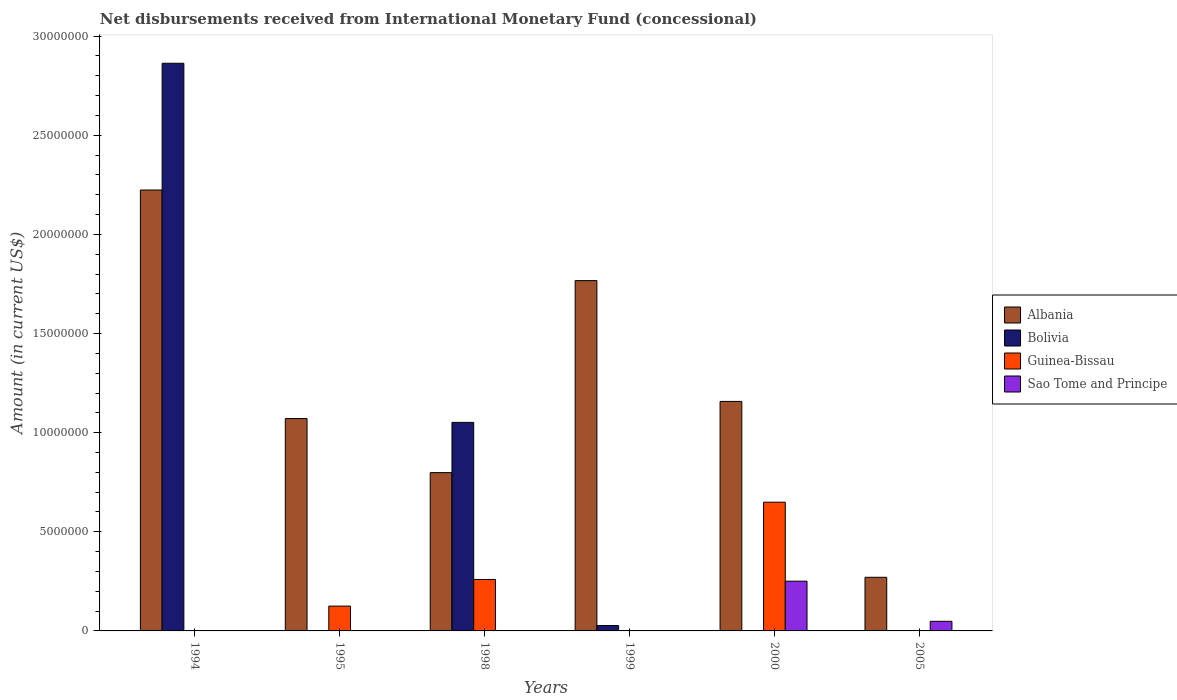How many different coloured bars are there?
Provide a short and direct response. 4. How many groups of bars are there?
Your answer should be compact. 6. Are the number of bars on each tick of the X-axis equal?
Keep it short and to the point. No. In how many cases, is the number of bars for a given year not equal to the number of legend labels?
Make the answer very short. 6. What is the amount of disbursements received from International Monetary Fund in Albania in 2005?
Provide a short and direct response. 2.70e+06. Across all years, what is the maximum amount of disbursements received from International Monetary Fund in Sao Tome and Principe?
Provide a succinct answer. 2.51e+06. Across all years, what is the minimum amount of disbursements received from International Monetary Fund in Albania?
Give a very brief answer. 2.70e+06. What is the total amount of disbursements received from International Monetary Fund in Guinea-Bissau in the graph?
Your answer should be compact. 1.03e+07. What is the difference between the amount of disbursements received from International Monetary Fund in Albania in 1995 and that in 1998?
Give a very brief answer. 2.73e+06. What is the difference between the amount of disbursements received from International Monetary Fund in Albania in 2000 and the amount of disbursements received from International Monetary Fund in Bolivia in 1995?
Keep it short and to the point. 1.16e+07. What is the average amount of disbursements received from International Monetary Fund in Albania per year?
Offer a very short reply. 1.21e+07. In the year 1994, what is the difference between the amount of disbursements received from International Monetary Fund in Albania and amount of disbursements received from International Monetary Fund in Bolivia?
Your response must be concise. -6.39e+06. In how many years, is the amount of disbursements received from International Monetary Fund in Guinea-Bissau greater than 6000000 US$?
Your response must be concise. 1. What is the difference between the highest and the second highest amount of disbursements received from International Monetary Fund in Albania?
Provide a succinct answer. 4.57e+06. What is the difference between the highest and the lowest amount of disbursements received from International Monetary Fund in Albania?
Offer a terse response. 1.95e+07. Is the sum of the amount of disbursements received from International Monetary Fund in Albania in 1994 and 1998 greater than the maximum amount of disbursements received from International Monetary Fund in Guinea-Bissau across all years?
Your answer should be compact. Yes. Is it the case that in every year, the sum of the amount of disbursements received from International Monetary Fund in Albania and amount of disbursements received from International Monetary Fund in Sao Tome and Principe is greater than the sum of amount of disbursements received from International Monetary Fund in Bolivia and amount of disbursements received from International Monetary Fund in Guinea-Bissau?
Ensure brevity in your answer.  Yes. Is it the case that in every year, the sum of the amount of disbursements received from International Monetary Fund in Albania and amount of disbursements received from International Monetary Fund in Guinea-Bissau is greater than the amount of disbursements received from International Monetary Fund in Sao Tome and Principe?
Provide a succinct answer. Yes. How many bars are there?
Provide a succinct answer. 14. What is the difference between two consecutive major ticks on the Y-axis?
Provide a succinct answer. 5.00e+06. How many legend labels are there?
Provide a short and direct response. 4. How are the legend labels stacked?
Provide a short and direct response. Vertical. What is the title of the graph?
Your answer should be compact. Net disbursements received from International Monetary Fund (concessional). Does "United Kingdom" appear as one of the legend labels in the graph?
Give a very brief answer. No. What is the Amount (in current US$) in Albania in 1994?
Give a very brief answer. 2.22e+07. What is the Amount (in current US$) of Bolivia in 1994?
Ensure brevity in your answer.  2.86e+07. What is the Amount (in current US$) of Guinea-Bissau in 1994?
Ensure brevity in your answer.  0. What is the Amount (in current US$) of Sao Tome and Principe in 1994?
Your answer should be compact. 0. What is the Amount (in current US$) of Albania in 1995?
Your answer should be very brief. 1.07e+07. What is the Amount (in current US$) of Guinea-Bissau in 1995?
Your answer should be very brief. 1.25e+06. What is the Amount (in current US$) of Sao Tome and Principe in 1995?
Keep it short and to the point. 0. What is the Amount (in current US$) in Albania in 1998?
Your response must be concise. 7.98e+06. What is the Amount (in current US$) of Bolivia in 1998?
Give a very brief answer. 1.05e+07. What is the Amount (in current US$) in Guinea-Bissau in 1998?
Keep it short and to the point. 2.60e+06. What is the Amount (in current US$) of Sao Tome and Principe in 1998?
Provide a short and direct response. 0. What is the Amount (in current US$) in Albania in 1999?
Provide a short and direct response. 1.77e+07. What is the Amount (in current US$) in Bolivia in 1999?
Make the answer very short. 2.72e+05. What is the Amount (in current US$) in Sao Tome and Principe in 1999?
Ensure brevity in your answer.  0. What is the Amount (in current US$) of Albania in 2000?
Ensure brevity in your answer.  1.16e+07. What is the Amount (in current US$) of Bolivia in 2000?
Provide a succinct answer. 0. What is the Amount (in current US$) of Guinea-Bissau in 2000?
Offer a terse response. 6.49e+06. What is the Amount (in current US$) of Sao Tome and Principe in 2000?
Give a very brief answer. 2.51e+06. What is the Amount (in current US$) of Albania in 2005?
Make the answer very short. 2.70e+06. What is the Amount (in current US$) in Bolivia in 2005?
Offer a very short reply. 0. What is the Amount (in current US$) in Sao Tome and Principe in 2005?
Make the answer very short. 4.85e+05. Across all years, what is the maximum Amount (in current US$) in Albania?
Your response must be concise. 2.22e+07. Across all years, what is the maximum Amount (in current US$) in Bolivia?
Your response must be concise. 2.86e+07. Across all years, what is the maximum Amount (in current US$) of Guinea-Bissau?
Offer a terse response. 6.49e+06. Across all years, what is the maximum Amount (in current US$) in Sao Tome and Principe?
Keep it short and to the point. 2.51e+06. Across all years, what is the minimum Amount (in current US$) of Albania?
Give a very brief answer. 2.70e+06. Across all years, what is the minimum Amount (in current US$) of Bolivia?
Offer a terse response. 0. Across all years, what is the minimum Amount (in current US$) of Sao Tome and Principe?
Offer a terse response. 0. What is the total Amount (in current US$) in Albania in the graph?
Give a very brief answer. 7.29e+07. What is the total Amount (in current US$) of Bolivia in the graph?
Make the answer very short. 3.94e+07. What is the total Amount (in current US$) of Guinea-Bissau in the graph?
Give a very brief answer. 1.03e+07. What is the total Amount (in current US$) of Sao Tome and Principe in the graph?
Keep it short and to the point. 2.99e+06. What is the difference between the Amount (in current US$) of Albania in 1994 and that in 1995?
Offer a terse response. 1.15e+07. What is the difference between the Amount (in current US$) in Albania in 1994 and that in 1998?
Provide a succinct answer. 1.43e+07. What is the difference between the Amount (in current US$) in Bolivia in 1994 and that in 1998?
Your answer should be compact. 1.81e+07. What is the difference between the Amount (in current US$) of Albania in 1994 and that in 1999?
Offer a terse response. 4.57e+06. What is the difference between the Amount (in current US$) in Bolivia in 1994 and that in 1999?
Give a very brief answer. 2.84e+07. What is the difference between the Amount (in current US$) of Albania in 1994 and that in 2000?
Ensure brevity in your answer.  1.07e+07. What is the difference between the Amount (in current US$) of Albania in 1994 and that in 2005?
Give a very brief answer. 1.95e+07. What is the difference between the Amount (in current US$) in Albania in 1995 and that in 1998?
Keep it short and to the point. 2.73e+06. What is the difference between the Amount (in current US$) in Guinea-Bissau in 1995 and that in 1998?
Provide a short and direct response. -1.34e+06. What is the difference between the Amount (in current US$) of Albania in 1995 and that in 1999?
Offer a very short reply. -6.96e+06. What is the difference between the Amount (in current US$) of Albania in 1995 and that in 2000?
Make the answer very short. -8.64e+05. What is the difference between the Amount (in current US$) of Guinea-Bissau in 1995 and that in 2000?
Keep it short and to the point. -5.24e+06. What is the difference between the Amount (in current US$) in Albania in 1995 and that in 2005?
Your answer should be very brief. 8.01e+06. What is the difference between the Amount (in current US$) in Albania in 1998 and that in 1999?
Your response must be concise. -9.68e+06. What is the difference between the Amount (in current US$) in Bolivia in 1998 and that in 1999?
Ensure brevity in your answer.  1.02e+07. What is the difference between the Amount (in current US$) in Albania in 1998 and that in 2000?
Your answer should be compact. -3.59e+06. What is the difference between the Amount (in current US$) in Guinea-Bissau in 1998 and that in 2000?
Make the answer very short. -3.90e+06. What is the difference between the Amount (in current US$) in Albania in 1998 and that in 2005?
Keep it short and to the point. 5.28e+06. What is the difference between the Amount (in current US$) in Albania in 1999 and that in 2000?
Your answer should be compact. 6.09e+06. What is the difference between the Amount (in current US$) of Albania in 1999 and that in 2005?
Your answer should be compact. 1.50e+07. What is the difference between the Amount (in current US$) in Albania in 2000 and that in 2005?
Your response must be concise. 8.87e+06. What is the difference between the Amount (in current US$) of Sao Tome and Principe in 2000 and that in 2005?
Your answer should be compact. 2.02e+06. What is the difference between the Amount (in current US$) in Albania in 1994 and the Amount (in current US$) in Guinea-Bissau in 1995?
Your answer should be compact. 2.10e+07. What is the difference between the Amount (in current US$) of Bolivia in 1994 and the Amount (in current US$) of Guinea-Bissau in 1995?
Keep it short and to the point. 2.74e+07. What is the difference between the Amount (in current US$) in Albania in 1994 and the Amount (in current US$) in Bolivia in 1998?
Give a very brief answer. 1.17e+07. What is the difference between the Amount (in current US$) in Albania in 1994 and the Amount (in current US$) in Guinea-Bissau in 1998?
Make the answer very short. 1.96e+07. What is the difference between the Amount (in current US$) in Bolivia in 1994 and the Amount (in current US$) in Guinea-Bissau in 1998?
Provide a short and direct response. 2.60e+07. What is the difference between the Amount (in current US$) of Albania in 1994 and the Amount (in current US$) of Bolivia in 1999?
Offer a very short reply. 2.20e+07. What is the difference between the Amount (in current US$) in Albania in 1994 and the Amount (in current US$) in Guinea-Bissau in 2000?
Your answer should be very brief. 1.57e+07. What is the difference between the Amount (in current US$) of Albania in 1994 and the Amount (in current US$) of Sao Tome and Principe in 2000?
Provide a succinct answer. 1.97e+07. What is the difference between the Amount (in current US$) in Bolivia in 1994 and the Amount (in current US$) in Guinea-Bissau in 2000?
Give a very brief answer. 2.21e+07. What is the difference between the Amount (in current US$) of Bolivia in 1994 and the Amount (in current US$) of Sao Tome and Principe in 2000?
Make the answer very short. 2.61e+07. What is the difference between the Amount (in current US$) in Albania in 1994 and the Amount (in current US$) in Sao Tome and Principe in 2005?
Make the answer very short. 2.18e+07. What is the difference between the Amount (in current US$) of Bolivia in 1994 and the Amount (in current US$) of Sao Tome and Principe in 2005?
Give a very brief answer. 2.81e+07. What is the difference between the Amount (in current US$) in Albania in 1995 and the Amount (in current US$) in Bolivia in 1998?
Your response must be concise. 1.93e+05. What is the difference between the Amount (in current US$) in Albania in 1995 and the Amount (in current US$) in Guinea-Bissau in 1998?
Give a very brief answer. 8.12e+06. What is the difference between the Amount (in current US$) in Albania in 1995 and the Amount (in current US$) in Bolivia in 1999?
Offer a terse response. 1.04e+07. What is the difference between the Amount (in current US$) of Albania in 1995 and the Amount (in current US$) of Guinea-Bissau in 2000?
Provide a short and direct response. 4.22e+06. What is the difference between the Amount (in current US$) in Albania in 1995 and the Amount (in current US$) in Sao Tome and Principe in 2000?
Offer a very short reply. 8.20e+06. What is the difference between the Amount (in current US$) in Guinea-Bissau in 1995 and the Amount (in current US$) in Sao Tome and Principe in 2000?
Give a very brief answer. -1.26e+06. What is the difference between the Amount (in current US$) of Albania in 1995 and the Amount (in current US$) of Sao Tome and Principe in 2005?
Offer a very short reply. 1.02e+07. What is the difference between the Amount (in current US$) of Guinea-Bissau in 1995 and the Amount (in current US$) of Sao Tome and Principe in 2005?
Offer a very short reply. 7.67e+05. What is the difference between the Amount (in current US$) in Albania in 1998 and the Amount (in current US$) in Bolivia in 1999?
Offer a very short reply. 7.71e+06. What is the difference between the Amount (in current US$) in Albania in 1998 and the Amount (in current US$) in Guinea-Bissau in 2000?
Provide a succinct answer. 1.49e+06. What is the difference between the Amount (in current US$) in Albania in 1998 and the Amount (in current US$) in Sao Tome and Principe in 2000?
Provide a succinct answer. 5.48e+06. What is the difference between the Amount (in current US$) in Bolivia in 1998 and the Amount (in current US$) in Guinea-Bissau in 2000?
Give a very brief answer. 4.03e+06. What is the difference between the Amount (in current US$) in Bolivia in 1998 and the Amount (in current US$) in Sao Tome and Principe in 2000?
Provide a short and direct response. 8.01e+06. What is the difference between the Amount (in current US$) of Guinea-Bissau in 1998 and the Amount (in current US$) of Sao Tome and Principe in 2000?
Provide a short and direct response. 8.60e+04. What is the difference between the Amount (in current US$) of Albania in 1998 and the Amount (in current US$) of Sao Tome and Principe in 2005?
Give a very brief answer. 7.50e+06. What is the difference between the Amount (in current US$) in Bolivia in 1998 and the Amount (in current US$) in Sao Tome and Principe in 2005?
Ensure brevity in your answer.  1.00e+07. What is the difference between the Amount (in current US$) in Guinea-Bissau in 1998 and the Amount (in current US$) in Sao Tome and Principe in 2005?
Your response must be concise. 2.11e+06. What is the difference between the Amount (in current US$) in Albania in 1999 and the Amount (in current US$) in Guinea-Bissau in 2000?
Make the answer very short. 1.12e+07. What is the difference between the Amount (in current US$) in Albania in 1999 and the Amount (in current US$) in Sao Tome and Principe in 2000?
Give a very brief answer. 1.52e+07. What is the difference between the Amount (in current US$) in Bolivia in 1999 and the Amount (in current US$) in Guinea-Bissau in 2000?
Your answer should be very brief. -6.22e+06. What is the difference between the Amount (in current US$) of Bolivia in 1999 and the Amount (in current US$) of Sao Tome and Principe in 2000?
Your response must be concise. -2.24e+06. What is the difference between the Amount (in current US$) of Albania in 1999 and the Amount (in current US$) of Sao Tome and Principe in 2005?
Make the answer very short. 1.72e+07. What is the difference between the Amount (in current US$) of Bolivia in 1999 and the Amount (in current US$) of Sao Tome and Principe in 2005?
Ensure brevity in your answer.  -2.13e+05. What is the difference between the Amount (in current US$) of Albania in 2000 and the Amount (in current US$) of Sao Tome and Principe in 2005?
Ensure brevity in your answer.  1.11e+07. What is the difference between the Amount (in current US$) in Guinea-Bissau in 2000 and the Amount (in current US$) in Sao Tome and Principe in 2005?
Your answer should be very brief. 6.01e+06. What is the average Amount (in current US$) of Albania per year?
Make the answer very short. 1.21e+07. What is the average Amount (in current US$) in Bolivia per year?
Your answer should be compact. 6.57e+06. What is the average Amount (in current US$) in Guinea-Bissau per year?
Ensure brevity in your answer.  1.72e+06. What is the average Amount (in current US$) in Sao Tome and Principe per year?
Your answer should be compact. 4.99e+05. In the year 1994, what is the difference between the Amount (in current US$) of Albania and Amount (in current US$) of Bolivia?
Your answer should be very brief. -6.39e+06. In the year 1995, what is the difference between the Amount (in current US$) of Albania and Amount (in current US$) of Guinea-Bissau?
Give a very brief answer. 9.46e+06. In the year 1998, what is the difference between the Amount (in current US$) in Albania and Amount (in current US$) in Bolivia?
Keep it short and to the point. -2.53e+06. In the year 1998, what is the difference between the Amount (in current US$) in Albania and Amount (in current US$) in Guinea-Bissau?
Your response must be concise. 5.39e+06. In the year 1998, what is the difference between the Amount (in current US$) of Bolivia and Amount (in current US$) of Guinea-Bissau?
Make the answer very short. 7.92e+06. In the year 1999, what is the difference between the Amount (in current US$) in Albania and Amount (in current US$) in Bolivia?
Make the answer very short. 1.74e+07. In the year 2000, what is the difference between the Amount (in current US$) of Albania and Amount (in current US$) of Guinea-Bissau?
Keep it short and to the point. 5.08e+06. In the year 2000, what is the difference between the Amount (in current US$) in Albania and Amount (in current US$) in Sao Tome and Principe?
Offer a terse response. 9.07e+06. In the year 2000, what is the difference between the Amount (in current US$) in Guinea-Bissau and Amount (in current US$) in Sao Tome and Principe?
Give a very brief answer. 3.98e+06. In the year 2005, what is the difference between the Amount (in current US$) of Albania and Amount (in current US$) of Sao Tome and Principe?
Offer a terse response. 2.22e+06. What is the ratio of the Amount (in current US$) of Albania in 1994 to that in 1995?
Give a very brief answer. 2.08. What is the ratio of the Amount (in current US$) of Albania in 1994 to that in 1998?
Provide a succinct answer. 2.79. What is the ratio of the Amount (in current US$) in Bolivia in 1994 to that in 1998?
Offer a very short reply. 2.72. What is the ratio of the Amount (in current US$) in Albania in 1994 to that in 1999?
Your answer should be compact. 1.26. What is the ratio of the Amount (in current US$) in Bolivia in 1994 to that in 1999?
Offer a terse response. 105.27. What is the ratio of the Amount (in current US$) of Albania in 1994 to that in 2000?
Provide a succinct answer. 1.92. What is the ratio of the Amount (in current US$) in Albania in 1994 to that in 2005?
Your response must be concise. 8.22. What is the ratio of the Amount (in current US$) in Albania in 1995 to that in 1998?
Provide a short and direct response. 1.34. What is the ratio of the Amount (in current US$) of Guinea-Bissau in 1995 to that in 1998?
Your answer should be very brief. 0.48. What is the ratio of the Amount (in current US$) in Albania in 1995 to that in 1999?
Your response must be concise. 0.61. What is the ratio of the Amount (in current US$) of Albania in 1995 to that in 2000?
Offer a terse response. 0.93. What is the ratio of the Amount (in current US$) in Guinea-Bissau in 1995 to that in 2000?
Make the answer very short. 0.19. What is the ratio of the Amount (in current US$) in Albania in 1995 to that in 2005?
Your response must be concise. 3.96. What is the ratio of the Amount (in current US$) in Albania in 1998 to that in 1999?
Ensure brevity in your answer.  0.45. What is the ratio of the Amount (in current US$) of Bolivia in 1998 to that in 1999?
Give a very brief answer. 38.67. What is the ratio of the Amount (in current US$) in Albania in 1998 to that in 2000?
Make the answer very short. 0.69. What is the ratio of the Amount (in current US$) in Guinea-Bissau in 1998 to that in 2000?
Your answer should be very brief. 0.4. What is the ratio of the Amount (in current US$) of Albania in 1998 to that in 2005?
Keep it short and to the point. 2.95. What is the ratio of the Amount (in current US$) of Albania in 1999 to that in 2000?
Offer a terse response. 1.53. What is the ratio of the Amount (in current US$) in Albania in 1999 to that in 2005?
Ensure brevity in your answer.  6.53. What is the ratio of the Amount (in current US$) of Albania in 2000 to that in 2005?
Your answer should be compact. 4.28. What is the ratio of the Amount (in current US$) in Sao Tome and Principe in 2000 to that in 2005?
Your answer should be very brief. 5.17. What is the difference between the highest and the second highest Amount (in current US$) of Albania?
Make the answer very short. 4.57e+06. What is the difference between the highest and the second highest Amount (in current US$) of Bolivia?
Keep it short and to the point. 1.81e+07. What is the difference between the highest and the second highest Amount (in current US$) in Guinea-Bissau?
Make the answer very short. 3.90e+06. What is the difference between the highest and the lowest Amount (in current US$) in Albania?
Keep it short and to the point. 1.95e+07. What is the difference between the highest and the lowest Amount (in current US$) in Bolivia?
Give a very brief answer. 2.86e+07. What is the difference between the highest and the lowest Amount (in current US$) of Guinea-Bissau?
Your response must be concise. 6.49e+06. What is the difference between the highest and the lowest Amount (in current US$) of Sao Tome and Principe?
Provide a succinct answer. 2.51e+06. 